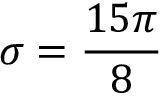Convert formula to latex. <formula><loc_0><loc_0><loc_500><loc_500>\sigma = \frac { 1 5 \pi } { 8 }</formula> 